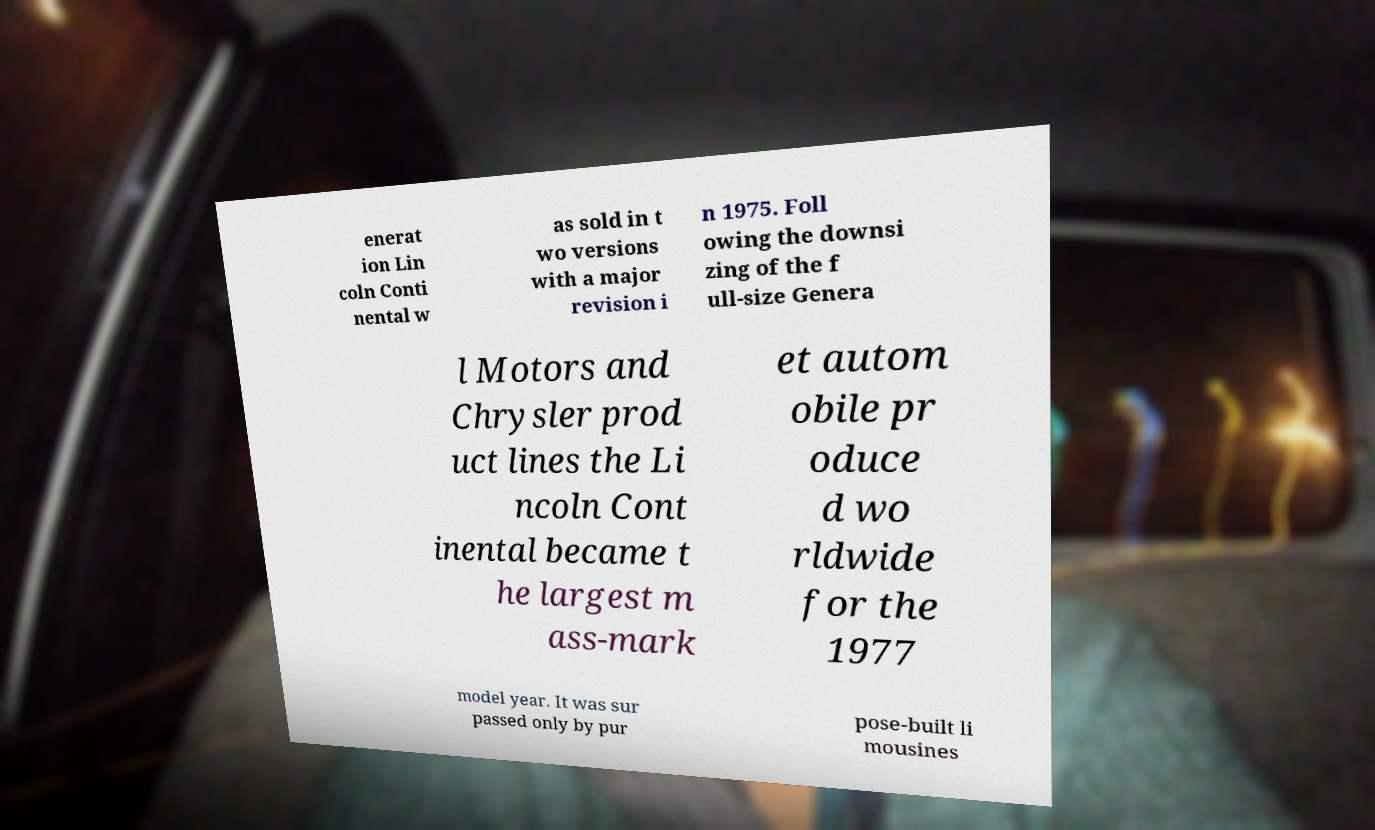Can you read and provide the text displayed in the image?This photo seems to have some interesting text. Can you extract and type it out for me? enerat ion Lin coln Conti nental w as sold in t wo versions with a major revision i n 1975. Foll owing the downsi zing of the f ull-size Genera l Motors and Chrysler prod uct lines the Li ncoln Cont inental became t he largest m ass-mark et autom obile pr oduce d wo rldwide for the 1977 model year. It was sur passed only by pur pose-built li mousines 